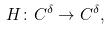Convert formula to latex. <formula><loc_0><loc_0><loc_500><loc_500>H \colon C ^ { \delta } \rightarrow C ^ { \delta } ,</formula> 